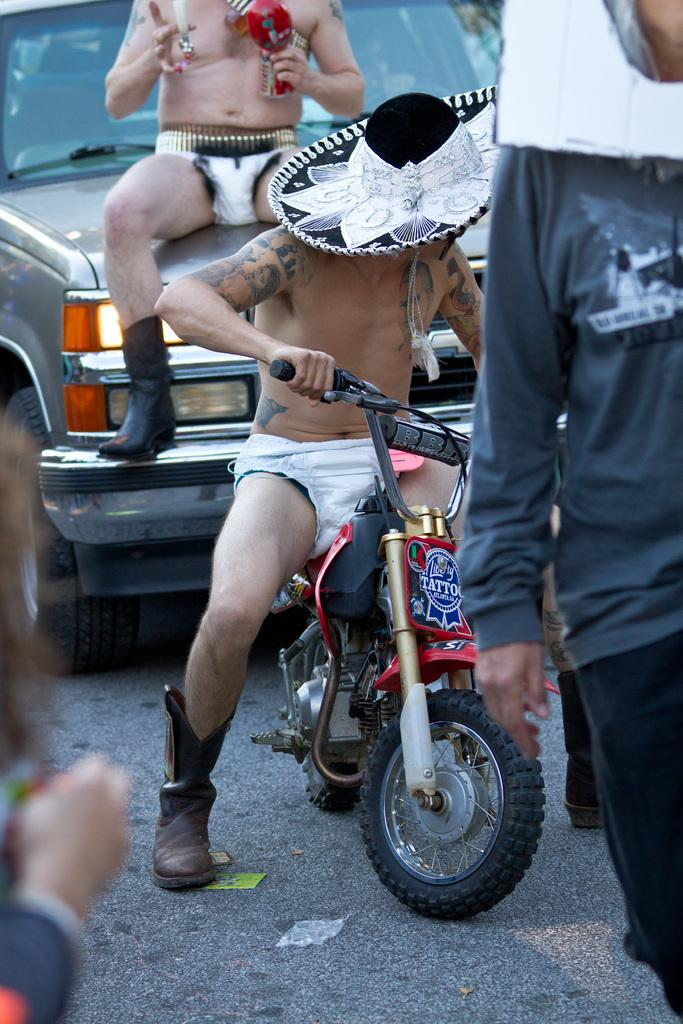What is the person doing in the image? The person is sitting on a motorbike. Can you describe the person's attire? The person is wearing a hat. What is the person holding in the image? The person is holding a tin. Where is the lunchroom located in the image? There is no lunchroom present in the image. How many chickens can be seen in the image? There are no chickens present in the image. 